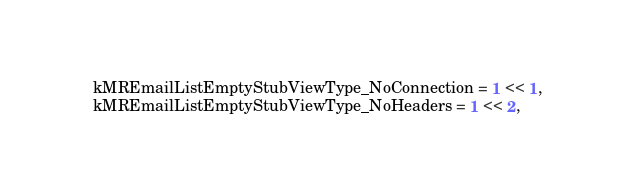Convert code to text. <code><loc_0><loc_0><loc_500><loc_500><_ObjectiveC_>    kMREmailListEmptyStubViewType_NoConnection = 1 << 1,
    kMREmailListEmptyStubViewType_NoHeaders = 1 << 2,</code> 